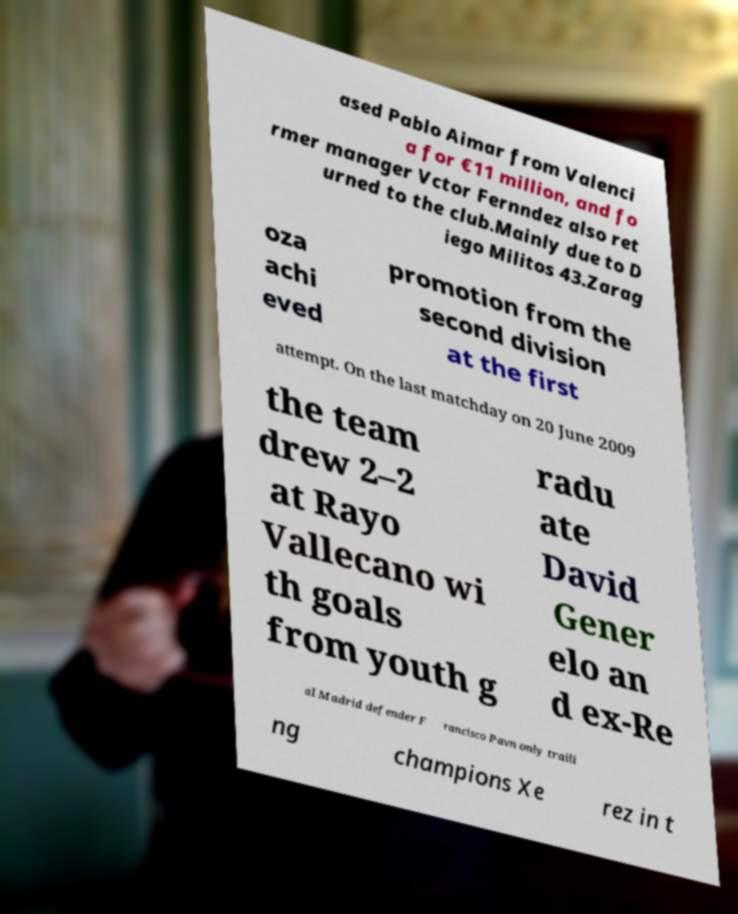Could you assist in decoding the text presented in this image and type it out clearly? ased Pablo Aimar from Valenci a for €11 million, and fo rmer manager Vctor Fernndez also ret urned to the club.Mainly due to D iego Militos 43.Zarag oza achi eved promotion from the second division at the first attempt. On the last matchday on 20 June 2009 the team drew 2–2 at Rayo Vallecano wi th goals from youth g radu ate David Gener elo an d ex-Re al Madrid defender F rancisco Pavn only traili ng champions Xe rez in t 